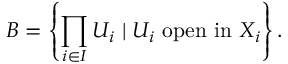<formula> <loc_0><loc_0><loc_500><loc_500>B = \left \{ \prod _ { i \in I } U _ { i } | U _ { i } { o p e n i n } X _ { i } \right \} .</formula> 